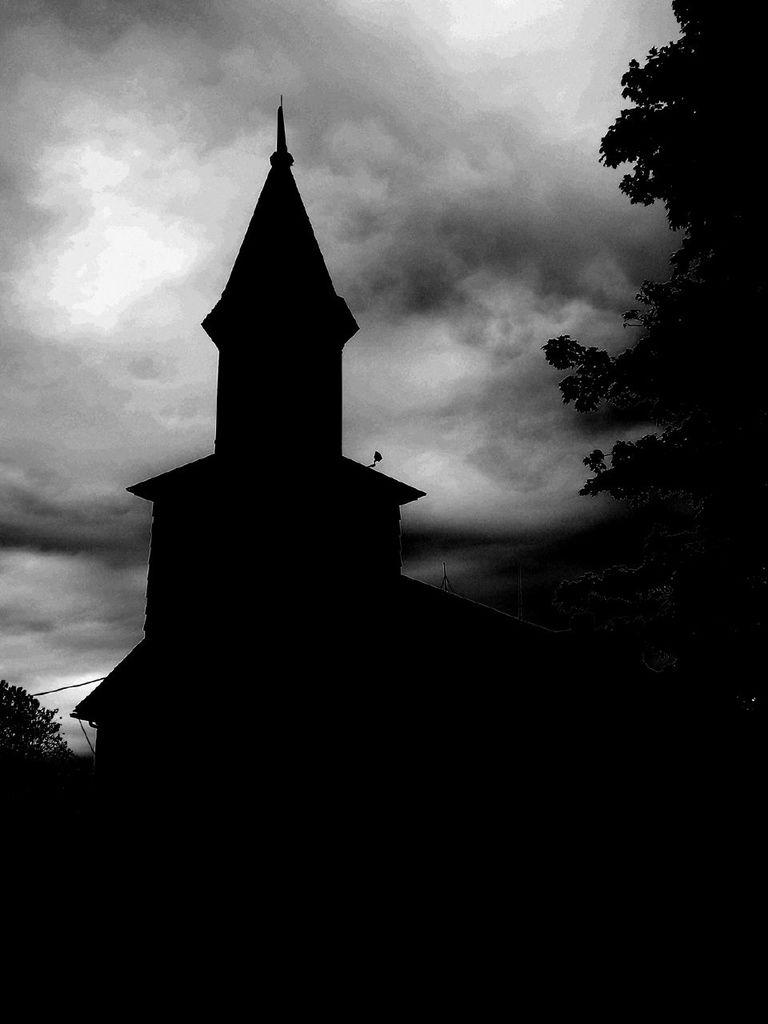What is the color scheme of the image? The image is black and white. What is the main subject in the center of the image? There is a building in the center of the image. What type of vegetation is on the right side of the image? There is a tree on the right side of the image. What type of story is being told by the tray in the image? There is no tray present in the image, so no story can be told by a tray. 